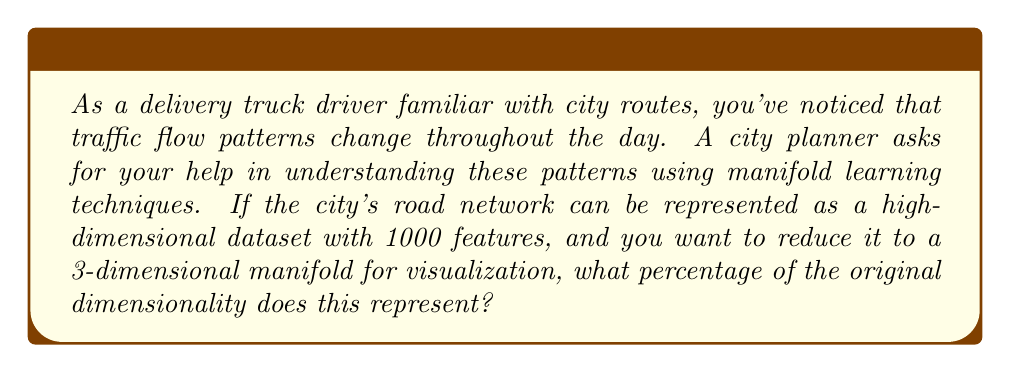Provide a solution to this math problem. To solve this problem, we need to understand the concept of dimensionality reduction in manifold learning and perform a simple calculation. Let's break it down step-by-step:

1. Original dimensionality:
   The city's road network is represented by a dataset with 1000 features.
   $$d_{original} = 1000$$

2. Reduced dimensionality:
   We want to reduce it to a 3-dimensional manifold.
   $$d_{reduced} = 3$$

3. To calculate the percentage, we use the formula:
   $$\text{Percentage} = \frac{d_{reduced}}{d_{original}} \times 100\%$$

4. Plugging in the values:
   $$\text{Percentage} = \frac{3}{1000} \times 100\%$$

5. Simplifying:
   $$\text{Percentage} = 0.003 \times 100\% = 0.3\%$$

This means that the 3-dimensional manifold represents 0.3% of the original 1000-dimensional dataset.
Answer: 0.3% 